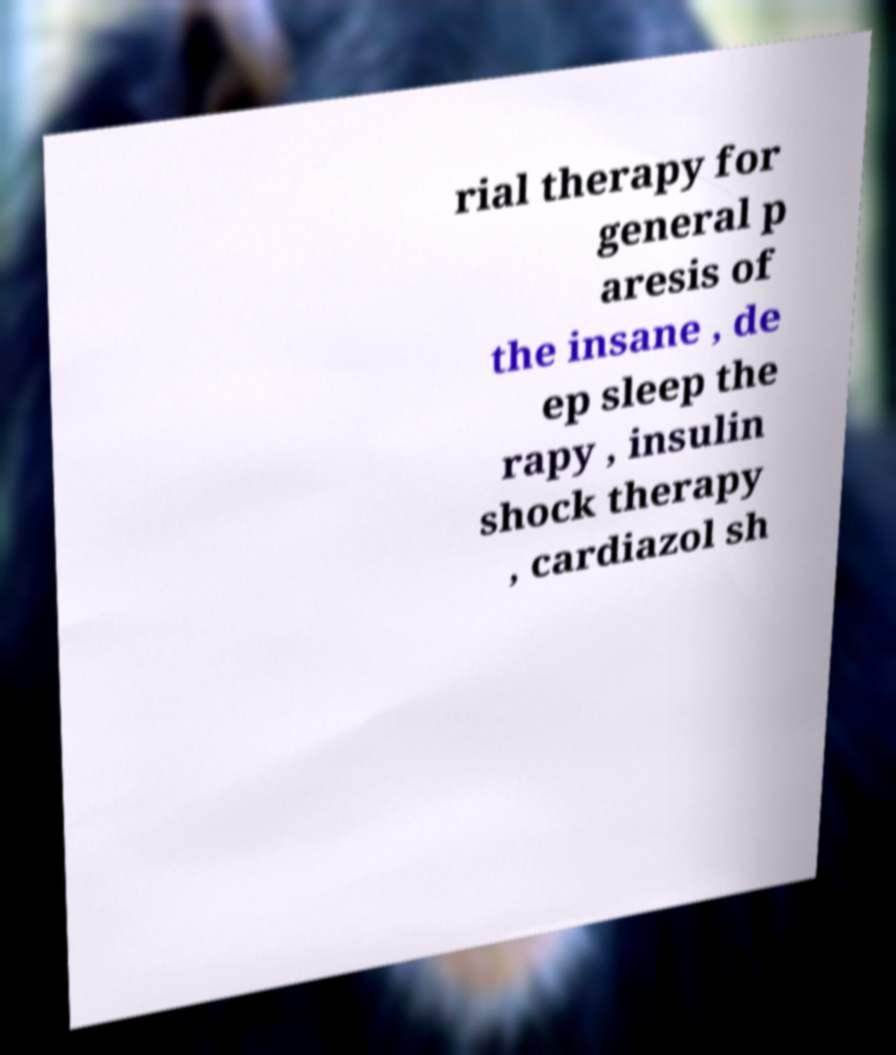Can you accurately transcribe the text from the provided image for me? rial therapy for general p aresis of the insane , de ep sleep the rapy , insulin shock therapy , cardiazol sh 